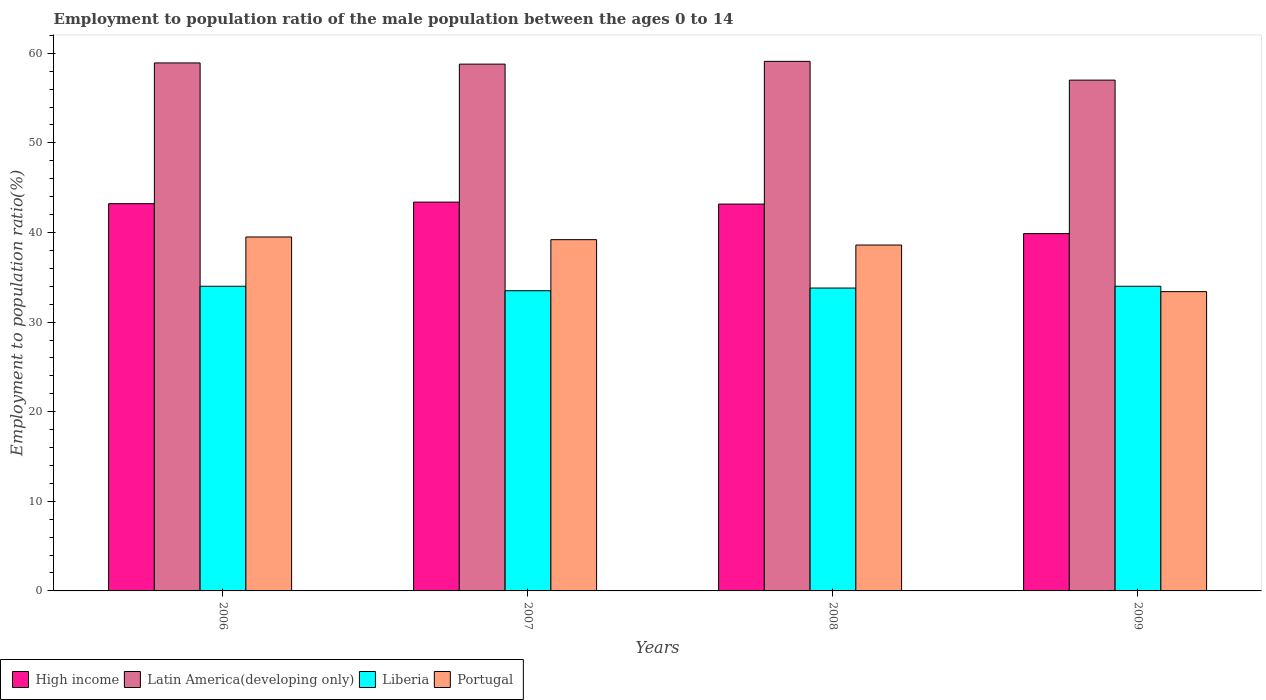How many different coloured bars are there?
Give a very brief answer. 4. How many groups of bars are there?
Provide a succinct answer. 4. Are the number of bars on each tick of the X-axis equal?
Offer a terse response. Yes. How many bars are there on the 2nd tick from the left?
Offer a terse response. 4. How many bars are there on the 2nd tick from the right?
Provide a short and direct response. 4. What is the employment to population ratio in Portugal in 2009?
Provide a succinct answer. 33.4. Across all years, what is the maximum employment to population ratio in Liberia?
Provide a short and direct response. 34. Across all years, what is the minimum employment to population ratio in Liberia?
Make the answer very short. 33.5. What is the total employment to population ratio in Portugal in the graph?
Offer a very short reply. 150.7. What is the difference between the employment to population ratio in Latin America(developing only) in 2008 and that in 2009?
Offer a very short reply. 2.1. What is the difference between the employment to population ratio in Latin America(developing only) in 2007 and the employment to population ratio in High income in 2008?
Your response must be concise. 15.62. What is the average employment to population ratio in Portugal per year?
Keep it short and to the point. 37.68. In the year 2009, what is the difference between the employment to population ratio in Portugal and employment to population ratio in High income?
Your response must be concise. -6.48. What is the ratio of the employment to population ratio in Portugal in 2006 to that in 2009?
Your answer should be very brief. 1.18. Is the difference between the employment to population ratio in Portugal in 2006 and 2009 greater than the difference between the employment to population ratio in High income in 2006 and 2009?
Provide a succinct answer. Yes. What is the difference between the highest and the lowest employment to population ratio in Liberia?
Provide a succinct answer. 0.5. Is the sum of the employment to population ratio in Liberia in 2006 and 2008 greater than the maximum employment to population ratio in High income across all years?
Offer a very short reply. Yes. Is it the case that in every year, the sum of the employment to population ratio in Liberia and employment to population ratio in Latin America(developing only) is greater than the sum of employment to population ratio in High income and employment to population ratio in Portugal?
Your answer should be compact. Yes. What does the 2nd bar from the left in 2009 represents?
Offer a very short reply. Latin America(developing only). What does the 2nd bar from the right in 2007 represents?
Provide a succinct answer. Liberia. Are all the bars in the graph horizontal?
Offer a very short reply. No. How many years are there in the graph?
Offer a very short reply. 4. Are the values on the major ticks of Y-axis written in scientific E-notation?
Offer a terse response. No. What is the title of the graph?
Provide a short and direct response. Employment to population ratio of the male population between the ages 0 to 14. What is the label or title of the Y-axis?
Offer a very short reply. Employment to population ratio(%). What is the Employment to population ratio(%) of High income in 2006?
Offer a very short reply. 43.22. What is the Employment to population ratio(%) in Latin America(developing only) in 2006?
Provide a succinct answer. 58.92. What is the Employment to population ratio(%) in Portugal in 2006?
Offer a very short reply. 39.5. What is the Employment to population ratio(%) in High income in 2007?
Your response must be concise. 43.39. What is the Employment to population ratio(%) in Latin America(developing only) in 2007?
Give a very brief answer. 58.79. What is the Employment to population ratio(%) of Liberia in 2007?
Provide a succinct answer. 33.5. What is the Employment to population ratio(%) in Portugal in 2007?
Offer a very short reply. 39.2. What is the Employment to population ratio(%) of High income in 2008?
Keep it short and to the point. 43.17. What is the Employment to population ratio(%) in Latin America(developing only) in 2008?
Make the answer very short. 59.1. What is the Employment to population ratio(%) in Liberia in 2008?
Your answer should be very brief. 33.8. What is the Employment to population ratio(%) in Portugal in 2008?
Your answer should be compact. 38.6. What is the Employment to population ratio(%) of High income in 2009?
Make the answer very short. 39.88. What is the Employment to population ratio(%) in Latin America(developing only) in 2009?
Offer a very short reply. 57. What is the Employment to population ratio(%) of Portugal in 2009?
Ensure brevity in your answer.  33.4. Across all years, what is the maximum Employment to population ratio(%) in High income?
Your answer should be compact. 43.39. Across all years, what is the maximum Employment to population ratio(%) in Latin America(developing only)?
Offer a very short reply. 59.1. Across all years, what is the maximum Employment to population ratio(%) in Liberia?
Make the answer very short. 34. Across all years, what is the maximum Employment to population ratio(%) in Portugal?
Ensure brevity in your answer.  39.5. Across all years, what is the minimum Employment to population ratio(%) of High income?
Give a very brief answer. 39.88. Across all years, what is the minimum Employment to population ratio(%) in Latin America(developing only)?
Your answer should be very brief. 57. Across all years, what is the minimum Employment to population ratio(%) of Liberia?
Your answer should be very brief. 33.5. Across all years, what is the minimum Employment to population ratio(%) of Portugal?
Your answer should be compact. 33.4. What is the total Employment to population ratio(%) in High income in the graph?
Make the answer very short. 169.65. What is the total Employment to population ratio(%) in Latin America(developing only) in the graph?
Provide a succinct answer. 233.81. What is the total Employment to population ratio(%) in Liberia in the graph?
Give a very brief answer. 135.3. What is the total Employment to population ratio(%) in Portugal in the graph?
Make the answer very short. 150.7. What is the difference between the Employment to population ratio(%) in High income in 2006 and that in 2007?
Provide a succinct answer. -0.17. What is the difference between the Employment to population ratio(%) of Latin America(developing only) in 2006 and that in 2007?
Provide a short and direct response. 0.13. What is the difference between the Employment to population ratio(%) of Portugal in 2006 and that in 2007?
Make the answer very short. 0.3. What is the difference between the Employment to population ratio(%) of High income in 2006 and that in 2008?
Provide a short and direct response. 0.04. What is the difference between the Employment to population ratio(%) of Latin America(developing only) in 2006 and that in 2008?
Your answer should be very brief. -0.18. What is the difference between the Employment to population ratio(%) of High income in 2006 and that in 2009?
Ensure brevity in your answer.  3.34. What is the difference between the Employment to population ratio(%) in Latin America(developing only) in 2006 and that in 2009?
Your response must be concise. 1.92. What is the difference between the Employment to population ratio(%) of Liberia in 2006 and that in 2009?
Ensure brevity in your answer.  0. What is the difference between the Employment to population ratio(%) in High income in 2007 and that in 2008?
Offer a very short reply. 0.22. What is the difference between the Employment to population ratio(%) of Latin America(developing only) in 2007 and that in 2008?
Give a very brief answer. -0.31. What is the difference between the Employment to population ratio(%) of Liberia in 2007 and that in 2008?
Provide a succinct answer. -0.3. What is the difference between the Employment to population ratio(%) in Portugal in 2007 and that in 2008?
Give a very brief answer. 0.6. What is the difference between the Employment to population ratio(%) in High income in 2007 and that in 2009?
Make the answer very short. 3.51. What is the difference between the Employment to population ratio(%) of Latin America(developing only) in 2007 and that in 2009?
Your answer should be compact. 1.79. What is the difference between the Employment to population ratio(%) in Liberia in 2007 and that in 2009?
Ensure brevity in your answer.  -0.5. What is the difference between the Employment to population ratio(%) in High income in 2008 and that in 2009?
Keep it short and to the point. 3.3. What is the difference between the Employment to population ratio(%) of Latin America(developing only) in 2008 and that in 2009?
Your answer should be compact. 2.1. What is the difference between the Employment to population ratio(%) in Liberia in 2008 and that in 2009?
Make the answer very short. -0.2. What is the difference between the Employment to population ratio(%) of Portugal in 2008 and that in 2009?
Offer a terse response. 5.2. What is the difference between the Employment to population ratio(%) of High income in 2006 and the Employment to population ratio(%) of Latin America(developing only) in 2007?
Give a very brief answer. -15.57. What is the difference between the Employment to population ratio(%) in High income in 2006 and the Employment to population ratio(%) in Liberia in 2007?
Provide a short and direct response. 9.72. What is the difference between the Employment to population ratio(%) in High income in 2006 and the Employment to population ratio(%) in Portugal in 2007?
Offer a terse response. 4.02. What is the difference between the Employment to population ratio(%) of Latin America(developing only) in 2006 and the Employment to population ratio(%) of Liberia in 2007?
Your response must be concise. 25.42. What is the difference between the Employment to population ratio(%) in Latin America(developing only) in 2006 and the Employment to population ratio(%) in Portugal in 2007?
Give a very brief answer. 19.72. What is the difference between the Employment to population ratio(%) of Liberia in 2006 and the Employment to population ratio(%) of Portugal in 2007?
Provide a succinct answer. -5.2. What is the difference between the Employment to population ratio(%) in High income in 2006 and the Employment to population ratio(%) in Latin America(developing only) in 2008?
Make the answer very short. -15.88. What is the difference between the Employment to population ratio(%) of High income in 2006 and the Employment to population ratio(%) of Liberia in 2008?
Give a very brief answer. 9.42. What is the difference between the Employment to population ratio(%) in High income in 2006 and the Employment to population ratio(%) in Portugal in 2008?
Give a very brief answer. 4.62. What is the difference between the Employment to population ratio(%) in Latin America(developing only) in 2006 and the Employment to population ratio(%) in Liberia in 2008?
Your response must be concise. 25.12. What is the difference between the Employment to population ratio(%) in Latin America(developing only) in 2006 and the Employment to population ratio(%) in Portugal in 2008?
Provide a short and direct response. 20.32. What is the difference between the Employment to population ratio(%) in High income in 2006 and the Employment to population ratio(%) in Latin America(developing only) in 2009?
Offer a very short reply. -13.79. What is the difference between the Employment to population ratio(%) in High income in 2006 and the Employment to population ratio(%) in Liberia in 2009?
Keep it short and to the point. 9.22. What is the difference between the Employment to population ratio(%) in High income in 2006 and the Employment to population ratio(%) in Portugal in 2009?
Provide a short and direct response. 9.82. What is the difference between the Employment to population ratio(%) in Latin America(developing only) in 2006 and the Employment to population ratio(%) in Liberia in 2009?
Your response must be concise. 24.92. What is the difference between the Employment to population ratio(%) of Latin America(developing only) in 2006 and the Employment to population ratio(%) of Portugal in 2009?
Your response must be concise. 25.52. What is the difference between the Employment to population ratio(%) of Liberia in 2006 and the Employment to population ratio(%) of Portugal in 2009?
Offer a very short reply. 0.6. What is the difference between the Employment to population ratio(%) of High income in 2007 and the Employment to population ratio(%) of Latin America(developing only) in 2008?
Give a very brief answer. -15.71. What is the difference between the Employment to population ratio(%) of High income in 2007 and the Employment to population ratio(%) of Liberia in 2008?
Provide a short and direct response. 9.59. What is the difference between the Employment to population ratio(%) in High income in 2007 and the Employment to population ratio(%) in Portugal in 2008?
Your answer should be compact. 4.79. What is the difference between the Employment to population ratio(%) of Latin America(developing only) in 2007 and the Employment to population ratio(%) of Liberia in 2008?
Offer a very short reply. 24.99. What is the difference between the Employment to population ratio(%) in Latin America(developing only) in 2007 and the Employment to population ratio(%) in Portugal in 2008?
Provide a succinct answer. 20.19. What is the difference between the Employment to population ratio(%) in Liberia in 2007 and the Employment to population ratio(%) in Portugal in 2008?
Your response must be concise. -5.1. What is the difference between the Employment to population ratio(%) in High income in 2007 and the Employment to population ratio(%) in Latin America(developing only) in 2009?
Ensure brevity in your answer.  -13.61. What is the difference between the Employment to population ratio(%) of High income in 2007 and the Employment to population ratio(%) of Liberia in 2009?
Your response must be concise. 9.39. What is the difference between the Employment to population ratio(%) in High income in 2007 and the Employment to population ratio(%) in Portugal in 2009?
Ensure brevity in your answer.  9.99. What is the difference between the Employment to population ratio(%) of Latin America(developing only) in 2007 and the Employment to population ratio(%) of Liberia in 2009?
Provide a succinct answer. 24.79. What is the difference between the Employment to population ratio(%) in Latin America(developing only) in 2007 and the Employment to population ratio(%) in Portugal in 2009?
Offer a very short reply. 25.39. What is the difference between the Employment to population ratio(%) in Liberia in 2007 and the Employment to population ratio(%) in Portugal in 2009?
Provide a succinct answer. 0.1. What is the difference between the Employment to population ratio(%) of High income in 2008 and the Employment to population ratio(%) of Latin America(developing only) in 2009?
Your response must be concise. -13.83. What is the difference between the Employment to population ratio(%) of High income in 2008 and the Employment to population ratio(%) of Liberia in 2009?
Offer a terse response. 9.17. What is the difference between the Employment to population ratio(%) in High income in 2008 and the Employment to population ratio(%) in Portugal in 2009?
Your answer should be very brief. 9.77. What is the difference between the Employment to population ratio(%) in Latin America(developing only) in 2008 and the Employment to population ratio(%) in Liberia in 2009?
Ensure brevity in your answer.  25.1. What is the difference between the Employment to population ratio(%) of Latin America(developing only) in 2008 and the Employment to population ratio(%) of Portugal in 2009?
Provide a succinct answer. 25.7. What is the difference between the Employment to population ratio(%) in Liberia in 2008 and the Employment to population ratio(%) in Portugal in 2009?
Your answer should be compact. 0.4. What is the average Employment to population ratio(%) in High income per year?
Give a very brief answer. 42.41. What is the average Employment to population ratio(%) of Latin America(developing only) per year?
Ensure brevity in your answer.  58.45. What is the average Employment to population ratio(%) in Liberia per year?
Offer a terse response. 33.83. What is the average Employment to population ratio(%) in Portugal per year?
Provide a short and direct response. 37.67. In the year 2006, what is the difference between the Employment to population ratio(%) of High income and Employment to population ratio(%) of Latin America(developing only)?
Provide a succinct answer. -15.71. In the year 2006, what is the difference between the Employment to population ratio(%) of High income and Employment to population ratio(%) of Liberia?
Your answer should be compact. 9.22. In the year 2006, what is the difference between the Employment to population ratio(%) of High income and Employment to population ratio(%) of Portugal?
Keep it short and to the point. 3.72. In the year 2006, what is the difference between the Employment to population ratio(%) of Latin America(developing only) and Employment to population ratio(%) of Liberia?
Ensure brevity in your answer.  24.92. In the year 2006, what is the difference between the Employment to population ratio(%) in Latin America(developing only) and Employment to population ratio(%) in Portugal?
Offer a terse response. 19.42. In the year 2007, what is the difference between the Employment to population ratio(%) in High income and Employment to population ratio(%) in Latin America(developing only)?
Your answer should be very brief. -15.4. In the year 2007, what is the difference between the Employment to population ratio(%) in High income and Employment to population ratio(%) in Liberia?
Provide a succinct answer. 9.89. In the year 2007, what is the difference between the Employment to population ratio(%) in High income and Employment to population ratio(%) in Portugal?
Keep it short and to the point. 4.19. In the year 2007, what is the difference between the Employment to population ratio(%) in Latin America(developing only) and Employment to population ratio(%) in Liberia?
Your answer should be very brief. 25.29. In the year 2007, what is the difference between the Employment to population ratio(%) in Latin America(developing only) and Employment to population ratio(%) in Portugal?
Your response must be concise. 19.59. In the year 2007, what is the difference between the Employment to population ratio(%) in Liberia and Employment to population ratio(%) in Portugal?
Provide a short and direct response. -5.7. In the year 2008, what is the difference between the Employment to population ratio(%) in High income and Employment to population ratio(%) in Latin America(developing only)?
Provide a succinct answer. -15.93. In the year 2008, what is the difference between the Employment to population ratio(%) in High income and Employment to population ratio(%) in Liberia?
Offer a very short reply. 9.37. In the year 2008, what is the difference between the Employment to population ratio(%) of High income and Employment to population ratio(%) of Portugal?
Your answer should be very brief. 4.57. In the year 2008, what is the difference between the Employment to population ratio(%) in Latin America(developing only) and Employment to population ratio(%) in Liberia?
Your answer should be very brief. 25.3. In the year 2008, what is the difference between the Employment to population ratio(%) of Latin America(developing only) and Employment to population ratio(%) of Portugal?
Offer a very short reply. 20.5. In the year 2008, what is the difference between the Employment to population ratio(%) of Liberia and Employment to population ratio(%) of Portugal?
Ensure brevity in your answer.  -4.8. In the year 2009, what is the difference between the Employment to population ratio(%) of High income and Employment to population ratio(%) of Latin America(developing only)?
Your answer should be compact. -17.13. In the year 2009, what is the difference between the Employment to population ratio(%) in High income and Employment to population ratio(%) in Liberia?
Provide a short and direct response. 5.88. In the year 2009, what is the difference between the Employment to population ratio(%) in High income and Employment to population ratio(%) in Portugal?
Make the answer very short. 6.48. In the year 2009, what is the difference between the Employment to population ratio(%) of Latin America(developing only) and Employment to population ratio(%) of Liberia?
Keep it short and to the point. 23. In the year 2009, what is the difference between the Employment to population ratio(%) in Latin America(developing only) and Employment to population ratio(%) in Portugal?
Offer a very short reply. 23.6. In the year 2009, what is the difference between the Employment to population ratio(%) of Liberia and Employment to population ratio(%) of Portugal?
Make the answer very short. 0.6. What is the ratio of the Employment to population ratio(%) of High income in 2006 to that in 2007?
Provide a succinct answer. 1. What is the ratio of the Employment to population ratio(%) in Liberia in 2006 to that in 2007?
Provide a short and direct response. 1.01. What is the ratio of the Employment to population ratio(%) of Portugal in 2006 to that in 2007?
Offer a terse response. 1.01. What is the ratio of the Employment to population ratio(%) of Latin America(developing only) in 2006 to that in 2008?
Keep it short and to the point. 1. What is the ratio of the Employment to population ratio(%) in Liberia in 2006 to that in 2008?
Give a very brief answer. 1.01. What is the ratio of the Employment to population ratio(%) of Portugal in 2006 to that in 2008?
Offer a very short reply. 1.02. What is the ratio of the Employment to population ratio(%) of High income in 2006 to that in 2009?
Make the answer very short. 1.08. What is the ratio of the Employment to population ratio(%) of Latin America(developing only) in 2006 to that in 2009?
Offer a terse response. 1.03. What is the ratio of the Employment to population ratio(%) in Portugal in 2006 to that in 2009?
Provide a succinct answer. 1.18. What is the ratio of the Employment to population ratio(%) of Latin America(developing only) in 2007 to that in 2008?
Your answer should be very brief. 0.99. What is the ratio of the Employment to population ratio(%) in Liberia in 2007 to that in 2008?
Your answer should be compact. 0.99. What is the ratio of the Employment to population ratio(%) of Portugal in 2007 to that in 2008?
Keep it short and to the point. 1.02. What is the ratio of the Employment to population ratio(%) of High income in 2007 to that in 2009?
Your answer should be very brief. 1.09. What is the ratio of the Employment to population ratio(%) in Latin America(developing only) in 2007 to that in 2009?
Your answer should be very brief. 1.03. What is the ratio of the Employment to population ratio(%) in Portugal in 2007 to that in 2009?
Your answer should be very brief. 1.17. What is the ratio of the Employment to population ratio(%) in High income in 2008 to that in 2009?
Provide a succinct answer. 1.08. What is the ratio of the Employment to population ratio(%) in Latin America(developing only) in 2008 to that in 2009?
Provide a succinct answer. 1.04. What is the ratio of the Employment to population ratio(%) of Liberia in 2008 to that in 2009?
Offer a terse response. 0.99. What is the ratio of the Employment to population ratio(%) of Portugal in 2008 to that in 2009?
Your response must be concise. 1.16. What is the difference between the highest and the second highest Employment to population ratio(%) of High income?
Your response must be concise. 0.17. What is the difference between the highest and the second highest Employment to population ratio(%) in Latin America(developing only)?
Offer a terse response. 0.18. What is the difference between the highest and the second highest Employment to population ratio(%) of Liberia?
Keep it short and to the point. 0. What is the difference between the highest and the lowest Employment to population ratio(%) in High income?
Offer a terse response. 3.51. What is the difference between the highest and the lowest Employment to population ratio(%) of Latin America(developing only)?
Offer a very short reply. 2.1. What is the difference between the highest and the lowest Employment to population ratio(%) of Liberia?
Make the answer very short. 0.5. 